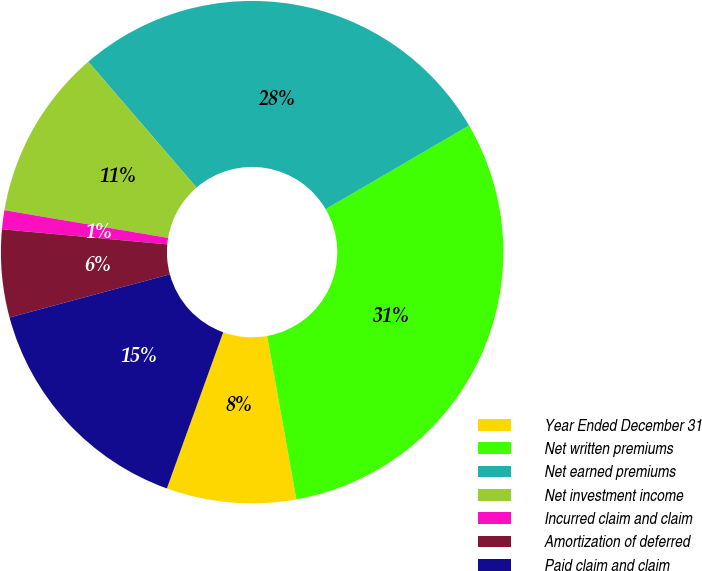Convert chart. <chart><loc_0><loc_0><loc_500><loc_500><pie_chart><fcel>Year Ended December 31<fcel>Net written premiums<fcel>Net earned premiums<fcel>Net investment income<fcel>Incurred claim and claim<fcel>Amortization of deferred<fcel>Paid claim and claim<nl><fcel>8.33%<fcel>30.59%<fcel>27.9%<fcel>11.02%<fcel>1.22%<fcel>5.64%<fcel>15.3%<nl></chart> 